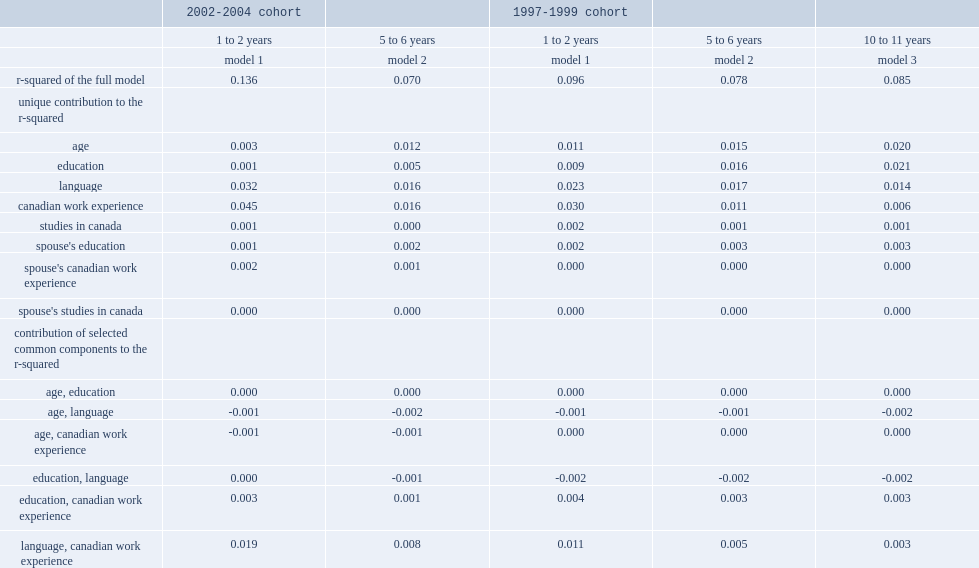What was the r-squared in model 1 for the 2002-2004 cohort? 0.136. What was the r-squared in the intermediate-term model (model 2) for the 2002-2004 cohort? 0.07. List the top2 contributions with the most predictive power regarding intermediate-term earnings. Language canadian work experience. Ater 10 to 11 years in canada,which variable had the most predictive power to the r-squared? Education. List the variable that had the next strongest predictor after 10 to 11 years. Age. What was the rate of language accounting for the r-squared after 10 to 11 years? 0.014. 